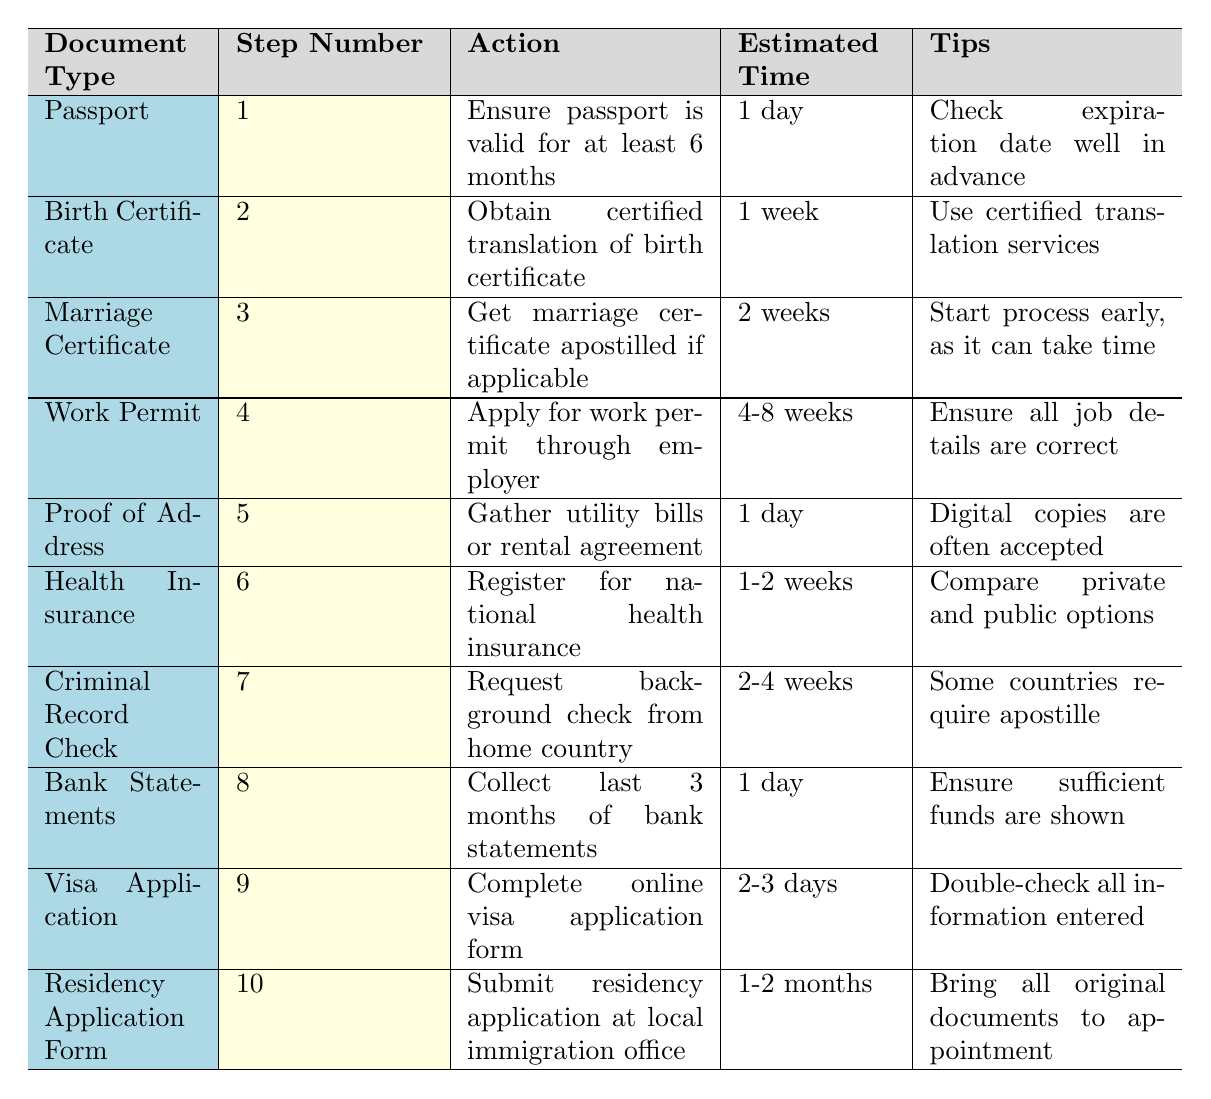What is the estimated time to obtain a marriage certificate? The estimated time for a marriage certificate is listed in the table as 2 weeks.
Answer: 2 weeks How many documents require an estimated time of 1 day? By reviewing the table, I can see that the documents with an estimated time of 1 day are Passport, Proof of Address, and Bank Statements, totaling 3 documents.
Answer: 3 documents Do you need to get a certified translation of the birth certificate? Yes, the table explicitly states that for the Birth Certificate, you need to obtain a certified translation.
Answer: Yes What is the action required for obtaining a work permit? According to the table, the action required is to apply for a work permit through an employer.
Answer: Apply for work permit through employer Which document has the longest estimated time, and how long is it? The residency application form has the longest estimated time of 1-2 months, which is mentioned in the table.
Answer: 1-2 months What is the estimated time range for collecting bank statements? The table indicates that collecting the last 3 months of bank statements takes 1 day.
Answer: 1 day If I start the process for a marriage certificate today, when can I expect to complete it? Since it takes an estimated 2 weeks to get the marriage certificate, if I start today, I can expect to complete it in 2 weeks.
Answer: In 2 weeks Are there any documents that require a background check? Yes, the Criminal Record Check document necessitates requesting a background check from the home country, as noted in the table.
Answer: Yes Which two documents require the longest processing times combined? The Work Permit (4-8 weeks) and the Residency Application Form (1-2 months) have the longest combined processing time, summing to a maximum range of approximately 2-4 months.
Answer: Work Permit and Residency Application Form What tips are provided for applying for a visa? The table suggests double-checking all information entered for the visa application.
Answer: Double-check all information entered 